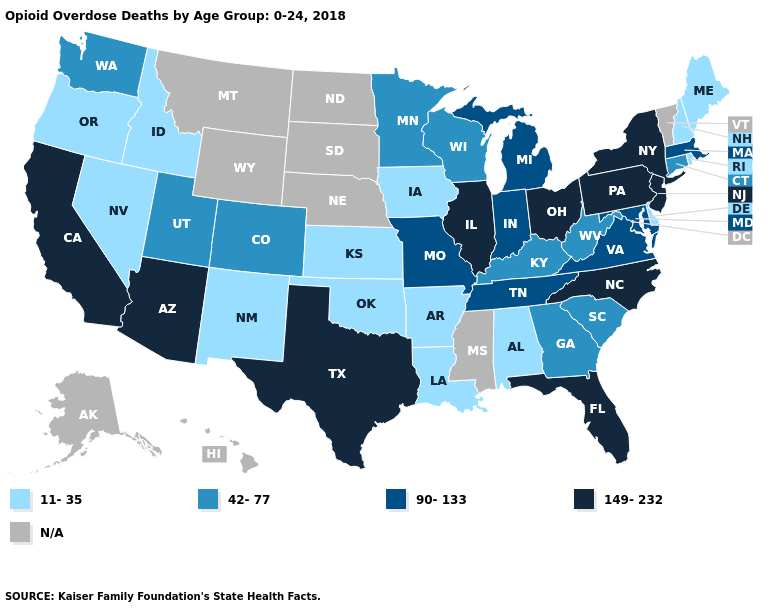Which states have the highest value in the USA?
Quick response, please. Arizona, California, Florida, Illinois, New Jersey, New York, North Carolina, Ohio, Pennsylvania, Texas. Which states have the highest value in the USA?
Answer briefly. Arizona, California, Florida, Illinois, New Jersey, New York, North Carolina, Ohio, Pennsylvania, Texas. Name the states that have a value in the range N/A?
Be succinct. Alaska, Hawaii, Mississippi, Montana, Nebraska, North Dakota, South Dakota, Vermont, Wyoming. Name the states that have a value in the range 42-77?
Write a very short answer. Colorado, Connecticut, Georgia, Kentucky, Minnesota, South Carolina, Utah, Washington, West Virginia, Wisconsin. Does the first symbol in the legend represent the smallest category?
Quick response, please. Yes. Name the states that have a value in the range 149-232?
Answer briefly. Arizona, California, Florida, Illinois, New Jersey, New York, North Carolina, Ohio, Pennsylvania, Texas. What is the lowest value in the USA?
Keep it brief. 11-35. What is the value of Alabama?
Write a very short answer. 11-35. Is the legend a continuous bar?
Short answer required. No. Which states have the highest value in the USA?
Quick response, please. Arizona, California, Florida, Illinois, New Jersey, New York, North Carolina, Ohio, Pennsylvania, Texas. What is the value of Colorado?
Short answer required. 42-77. What is the value of Maine?
Write a very short answer. 11-35. Is the legend a continuous bar?
Short answer required. No. Does Tennessee have the lowest value in the South?
Quick response, please. No. Name the states that have a value in the range N/A?
Write a very short answer. Alaska, Hawaii, Mississippi, Montana, Nebraska, North Dakota, South Dakota, Vermont, Wyoming. 